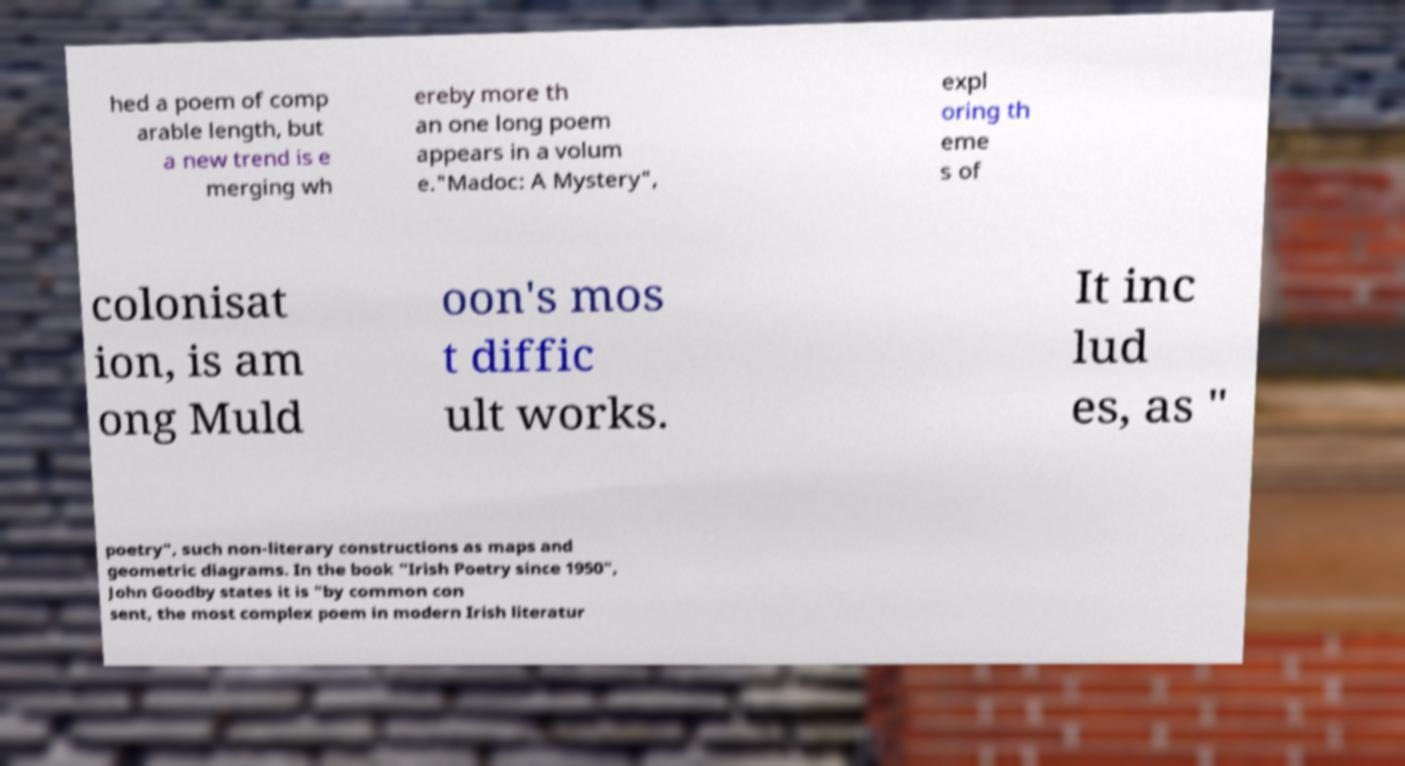For documentation purposes, I need the text within this image transcribed. Could you provide that? hed a poem of comp arable length, but a new trend is e merging wh ereby more th an one long poem appears in a volum e."Madoc: A Mystery", expl oring th eme s of colonisat ion, is am ong Muld oon's mos t diffic ult works. It inc lud es, as " poetry", such non-literary constructions as maps and geometric diagrams. In the book "Irish Poetry since 1950", John Goodby states it is "by common con sent, the most complex poem in modern Irish literatur 